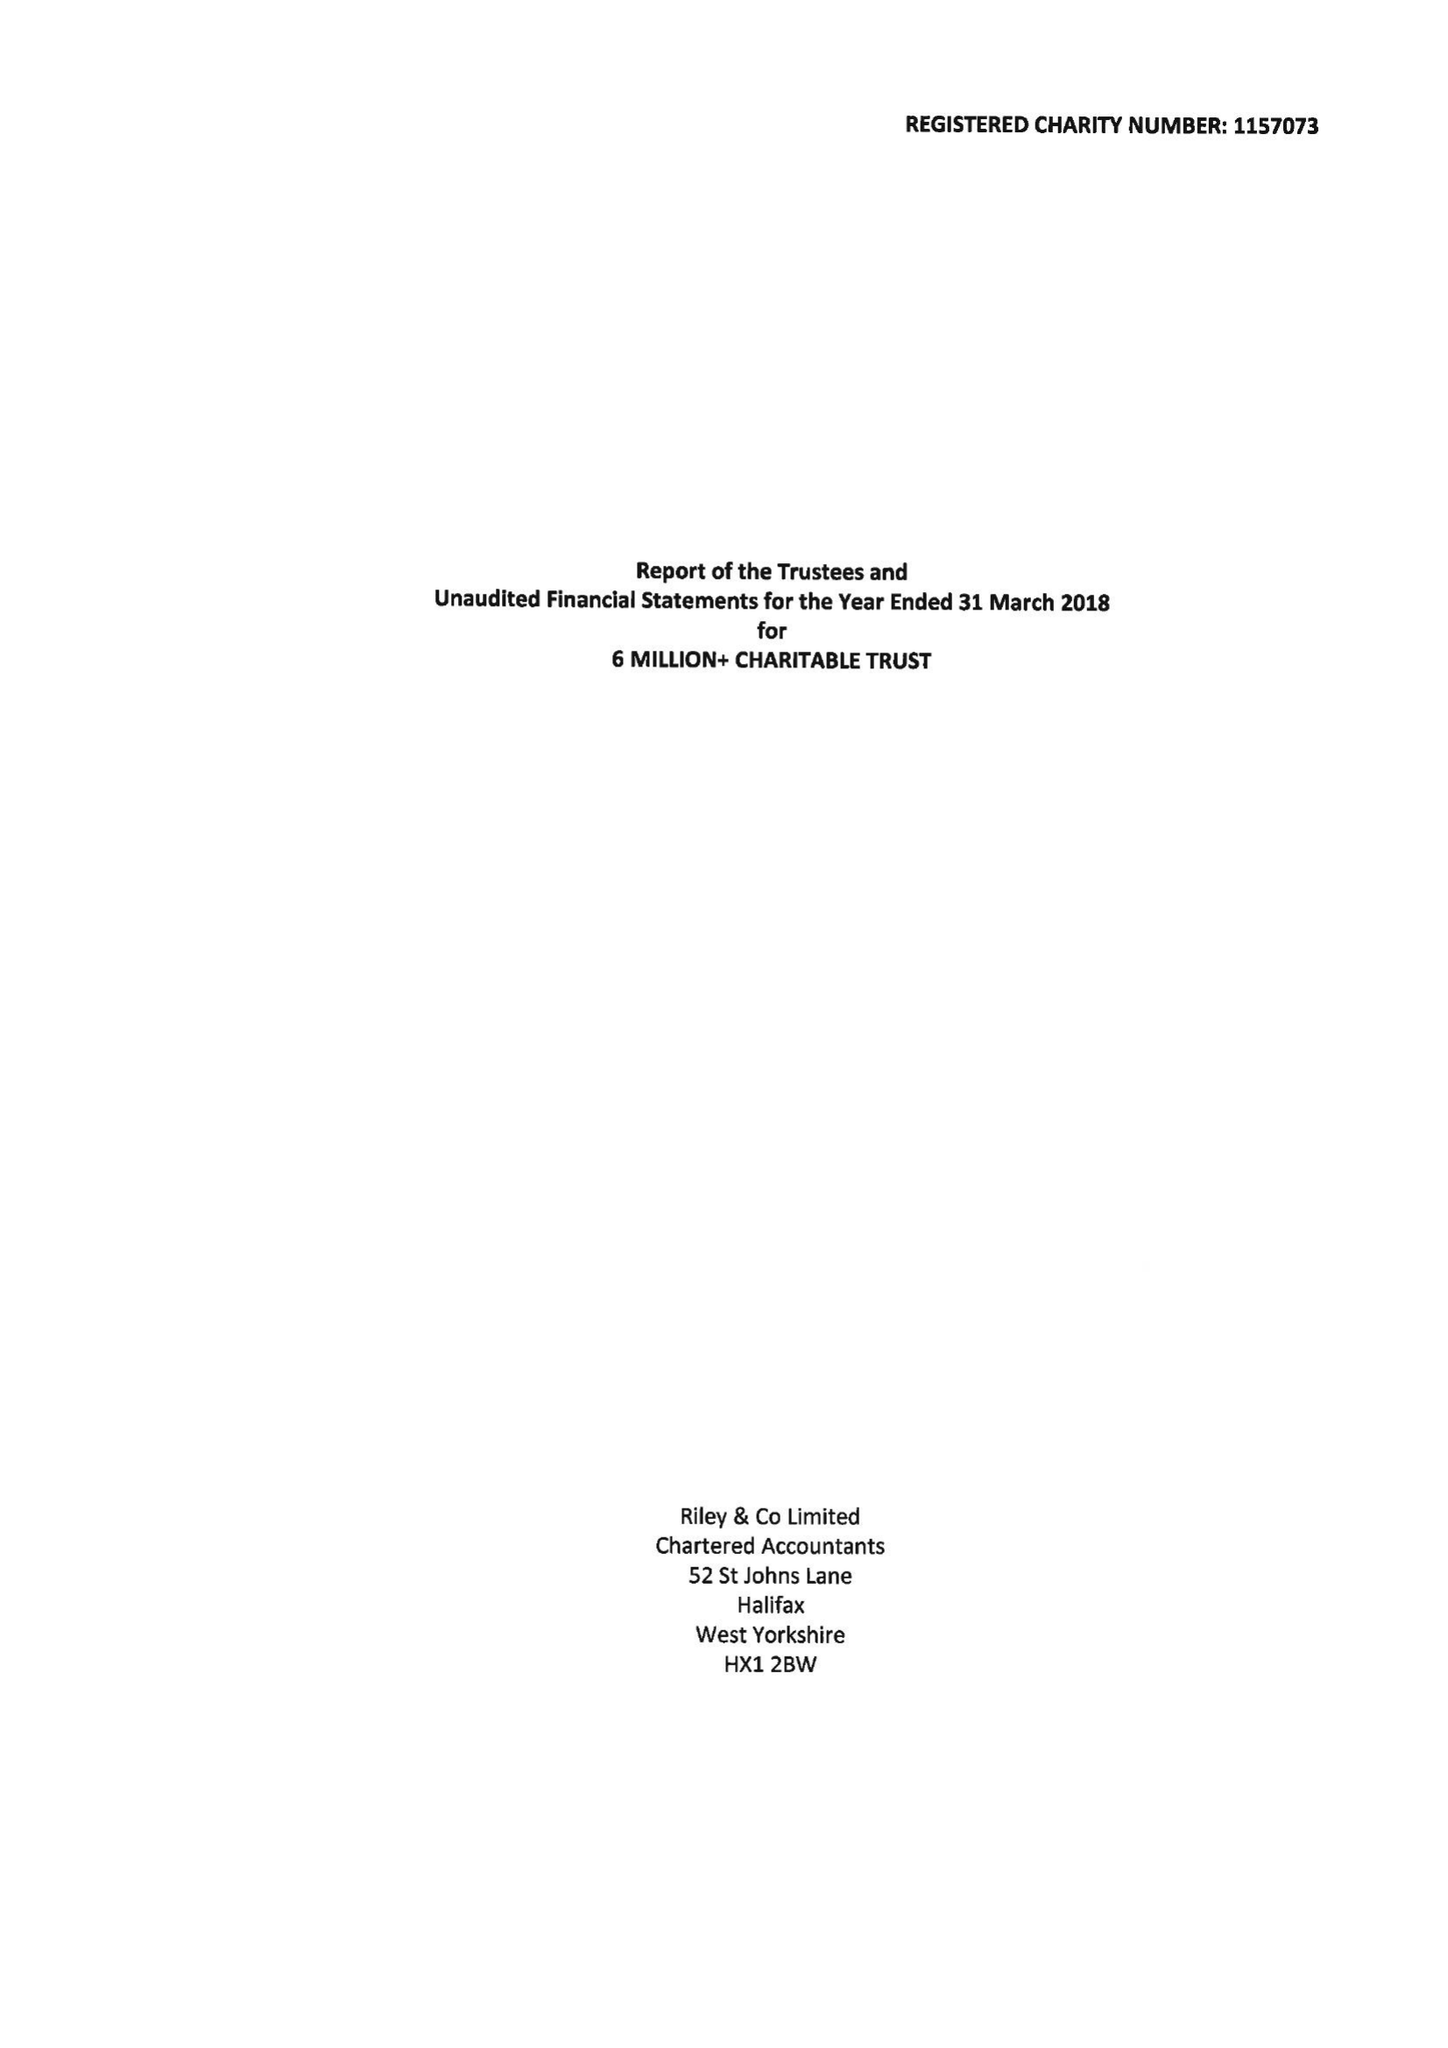What is the value for the address__street_line?
Answer the question using a single word or phrase. None 